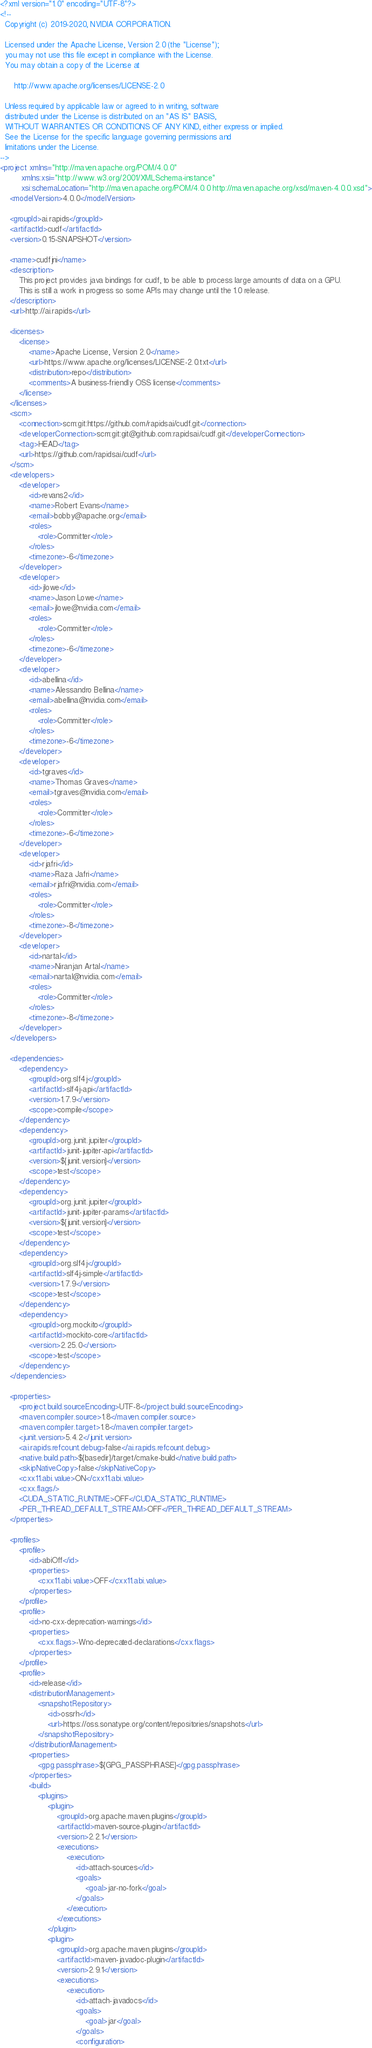Convert code to text. <code><loc_0><loc_0><loc_500><loc_500><_XML_><?xml version="1.0" encoding="UTF-8"?>
<!--
  Copyright (c) 2019-2020, NVIDIA CORPORATION.

  Licensed under the Apache License, Version 2.0 (the "License");
  you may not use this file except in compliance with the License.
  You may obtain a copy of the License at

      http://www.apache.org/licenses/LICENSE-2.0

  Unless required by applicable law or agreed to in writing, software
  distributed under the License is distributed on an "AS IS" BASIS,
  WITHOUT WARRANTIES OR CONDITIONS OF ANY KIND, either express or implied.
  See the License for the specific language governing permissions and
  limitations under the License.
-->
<project xmlns="http://maven.apache.org/POM/4.0.0"
         xmlns:xsi="http://www.w3.org/2001/XMLSchema-instance"
         xsi:schemaLocation="http://maven.apache.org/POM/4.0.0 http://maven.apache.org/xsd/maven-4.0.0.xsd">
    <modelVersion>4.0.0</modelVersion>

    <groupId>ai.rapids</groupId>
    <artifactId>cudf</artifactId>
    <version>0.15-SNAPSHOT</version>

    <name>cudfjni</name>
    <description>
        This project provides java bindings for cudf, to be able to process large amounts of data on a GPU.
        This is still a work in progress so some APIs may change until the 1.0 release.
    </description>
    <url>http://ai.rapids</url>

    <licenses>
        <license>
            <name>Apache License, Version 2.0</name>
            <url>https://www.apache.org/licenses/LICENSE-2.0.txt</url>
            <distribution>repo</distribution>
            <comments>A business-friendly OSS license</comments>
        </license>
    </licenses>
    <scm>
        <connection>scm:git:https://github.com/rapidsai/cudf.git</connection>
        <developerConnection>scm:git:git@github.com:rapidsai/cudf.git</developerConnection>
        <tag>HEAD</tag>
        <url>https://github.com/rapidsai/cudf</url>
    </scm>
    <developers>
        <developer>
            <id>revans2</id>
            <name>Robert Evans</name>
            <email>bobby@apache.org</email>
            <roles>
                <role>Committer</role>
            </roles>
            <timezone>-6</timezone>
        </developer>
        <developer>
            <id>jlowe</id>
            <name>Jason Lowe</name>
            <email>jlowe@nvidia.com</email>
            <roles>
                <role>Committer</role>
            </roles>
            <timezone>-6</timezone>
        </developer>
        <developer>
            <id>abellina</id>
            <name>Alessandro Bellina</name>
            <email>abellina@nvidia.com</email>
            <roles>
                <role>Committer</role>
            </roles>
            <timezone>-6</timezone>
        </developer>
        <developer>
            <id>tgraves</id>
            <name>Thomas Graves</name>
            <email>tgraves@nvidia.com</email>
            <roles>
                <role>Committer</role>
            </roles>
            <timezone>-6</timezone>
        </developer>
        <developer>
            <id>rjafri</id>
            <name>Raza Jafri</name>
            <email>rjafri@nvidia.com</email>
            <roles>
                <role>Committer</role>
            </roles>
            <timezone>-8</timezone>
        </developer>
        <developer>
            <id>nartal</id>
            <name>Niranjan Artal</name>
            <email>nartal@nvidia.com</email>
            <roles>
                <role>Committer</role>
            </roles>
            <timezone>-8</timezone>
        </developer>
    </developers>

    <dependencies>
        <dependency>
            <groupId>org.slf4j</groupId>
            <artifactId>slf4j-api</artifactId>
            <version>1.7.9</version>
            <scope>compile</scope>
        </dependency>
        <dependency>
            <groupId>org.junit.jupiter</groupId>
            <artifactId>junit-jupiter-api</artifactId>
            <version>${junit.version}</version>
            <scope>test</scope>
        </dependency>
        <dependency>
            <groupId>org.junit.jupiter</groupId>
            <artifactId>junit-jupiter-params</artifactId>
            <version>${junit.version}</version>
            <scope>test</scope>
        </dependency>
        <dependency>
            <groupId>org.slf4j</groupId>
            <artifactId>slf4j-simple</artifactId>
            <version>1.7.9</version>
            <scope>test</scope>
        </dependency>
        <dependency>
            <groupId>org.mockito</groupId>
            <artifactId>mockito-core</artifactId>
            <version>2.25.0</version>
            <scope>test</scope>
        </dependency>
    </dependencies>

    <properties>
        <project.build.sourceEncoding>UTF-8</project.build.sourceEncoding>
        <maven.compiler.source>1.8</maven.compiler.source>
        <maven.compiler.target>1.8</maven.compiler.target>
        <junit.version>5.4.2</junit.version>
        <ai.rapids.refcount.debug>false</ai.rapids.refcount.debug>
        <native.build.path>${basedir}/target/cmake-build</native.build.path>
        <skipNativeCopy>false</skipNativeCopy>
        <cxx11.abi.value>ON</cxx11.abi.value>
        <cxx.flags/>
        <CUDA_STATIC_RUNTIME>OFF</CUDA_STATIC_RUNTIME>
        <PER_THREAD_DEFAULT_STREAM>OFF</PER_THREAD_DEFAULT_STREAM>
    </properties>

    <profiles>
        <profile>
            <id>abiOff</id>
            <properties>
                <cxx11.abi.value>OFF</cxx11.abi.value>
            </properties>
        </profile>
        <profile>
            <id>no-cxx-deprecation-warnings</id>
            <properties>
                <cxx.flags>-Wno-deprecated-declarations</cxx.flags>
            </properties>
        </profile>
        <profile>
            <id>release</id>
            <distributionManagement>
                <snapshotRepository>
                    <id>ossrh</id>
                    <url>https://oss.sonatype.org/content/repositories/snapshots</url>
                </snapshotRepository>
            </distributionManagement>
            <properties>
                <gpg.passphrase>${GPG_PASSPHRASE}</gpg.passphrase>
            </properties>
            <build>
                <plugins>
                    <plugin>
                        <groupId>org.apache.maven.plugins</groupId>
                        <artifactId>maven-source-plugin</artifactId>
                        <version>2.2.1</version>
                        <executions>
                            <execution>
                                <id>attach-sources</id>
                                <goals>
                                    <goal>jar-no-fork</goal>
                                </goals>
                            </execution>
                        </executions>
                    </plugin>
                    <plugin>
                        <groupId>org.apache.maven.plugins</groupId>
                        <artifactId>maven-javadoc-plugin</artifactId>
                        <version>2.9.1</version>
                        <executions>
                            <execution>
                                <id>attach-javadocs</id>
                                <goals>
                                    <goal>jar</goal>
                                </goals>
                                <configuration></code> 